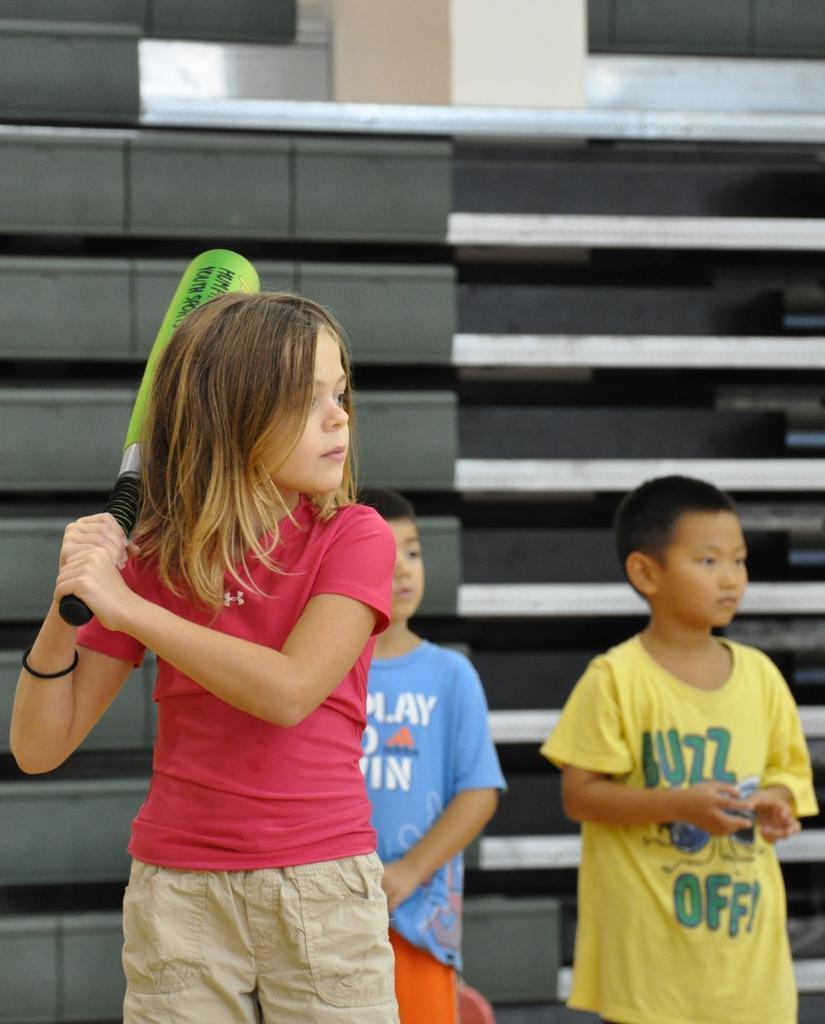Describe this image in one or two sentences. In this picture we can see few kids, on the left side of the image we can see a girl, she is holding a bat, and on the right side of the image we can see a boy, he wore a yellow color T-shirt. 